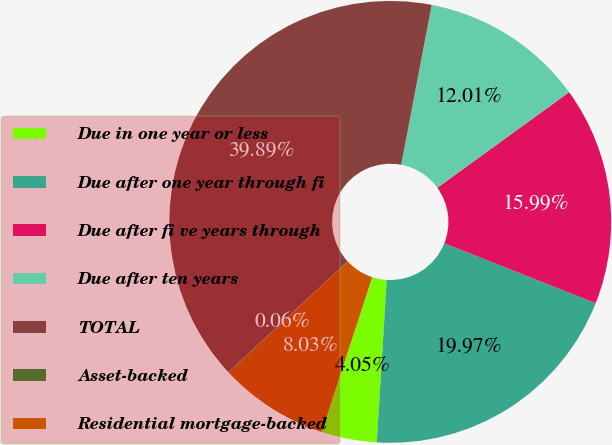Convert chart to OTSL. <chart><loc_0><loc_0><loc_500><loc_500><pie_chart><fcel>Due in one year or less<fcel>Due after one year through fi<fcel>Due after fi ve years through<fcel>Due after ten years<fcel>TOTAL<fcel>Asset-backed<fcel>Residential mortgage-backed<nl><fcel>4.05%<fcel>19.97%<fcel>15.99%<fcel>12.01%<fcel>39.89%<fcel>0.06%<fcel>8.03%<nl></chart> 